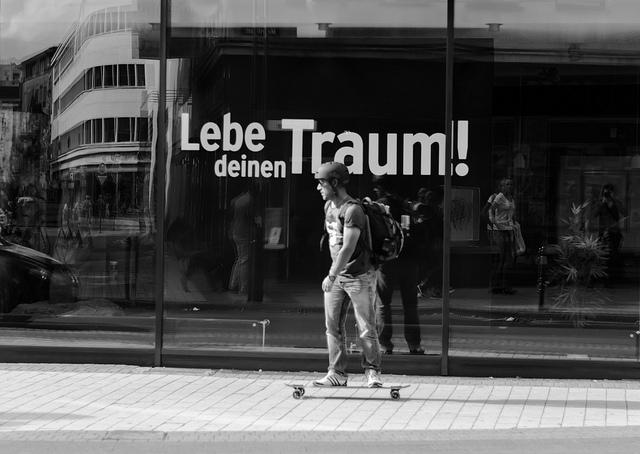What time of day is it likely to be? afternoon 